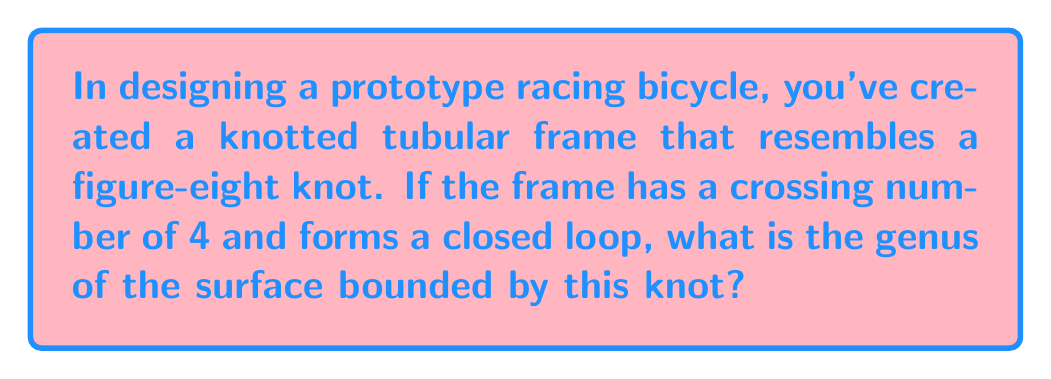Help me with this question. To evaluate the genus of the surface bounded by the knotted tubular frame, we'll follow these steps:

1. Identify the knot: The frame resembles a figure-eight knot with a crossing number of 4.

2. Use the formula for the genus of a knot:
   $$g = \frac{1}{2}(c - n + 1)$$
   where $g$ is the genus, $c$ is the crossing number, and $n$ is the number of components in the link.

3. Apply the given information:
   - Crossing number $(c) = 4$
   - Number of components $(n) = 1$ (single closed loop)

4. Substitute these values into the formula:
   $$g = \frac{1}{2}(4 - 1 + 1)$$
   $$g = \frac{1}{2}(4)$$
   $$g = 2$$

5. Interpret the result: The genus of the surface bounded by this knotted tubular frame is 1, which means it's topologically equivalent to a torus with one hole.

This genus value indicates the complexity of the knot and the surface it bounds, which could affect the bicycle's aerodynamics and structural integrity.
Answer: $1$ 